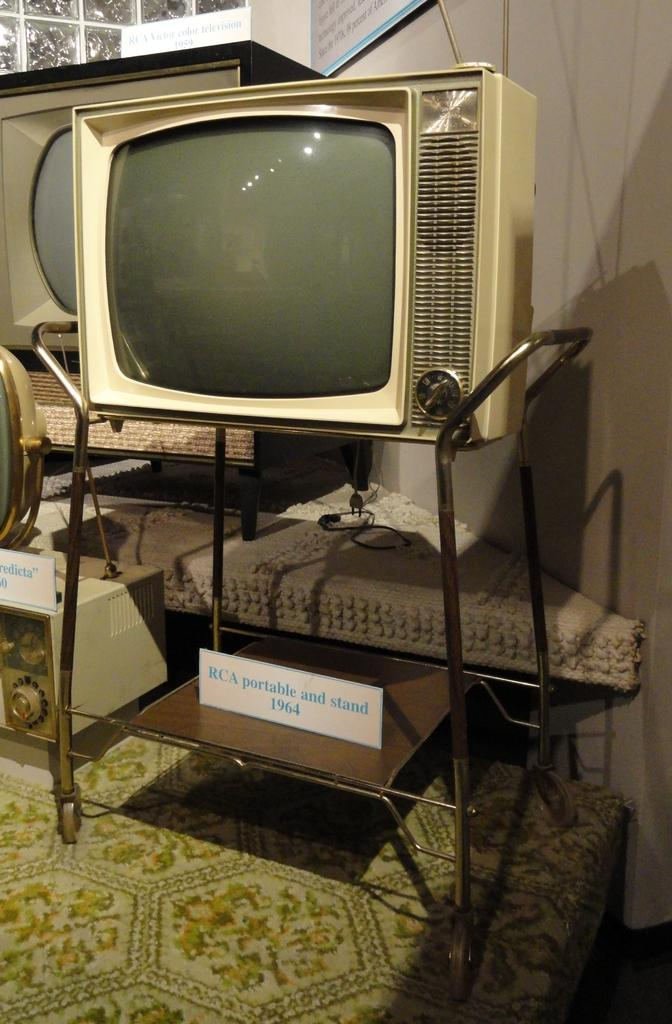<image>
Render a clear and concise summary of the photo. 1964 Television and portable television stand with other antique televisions and radios in the background. 